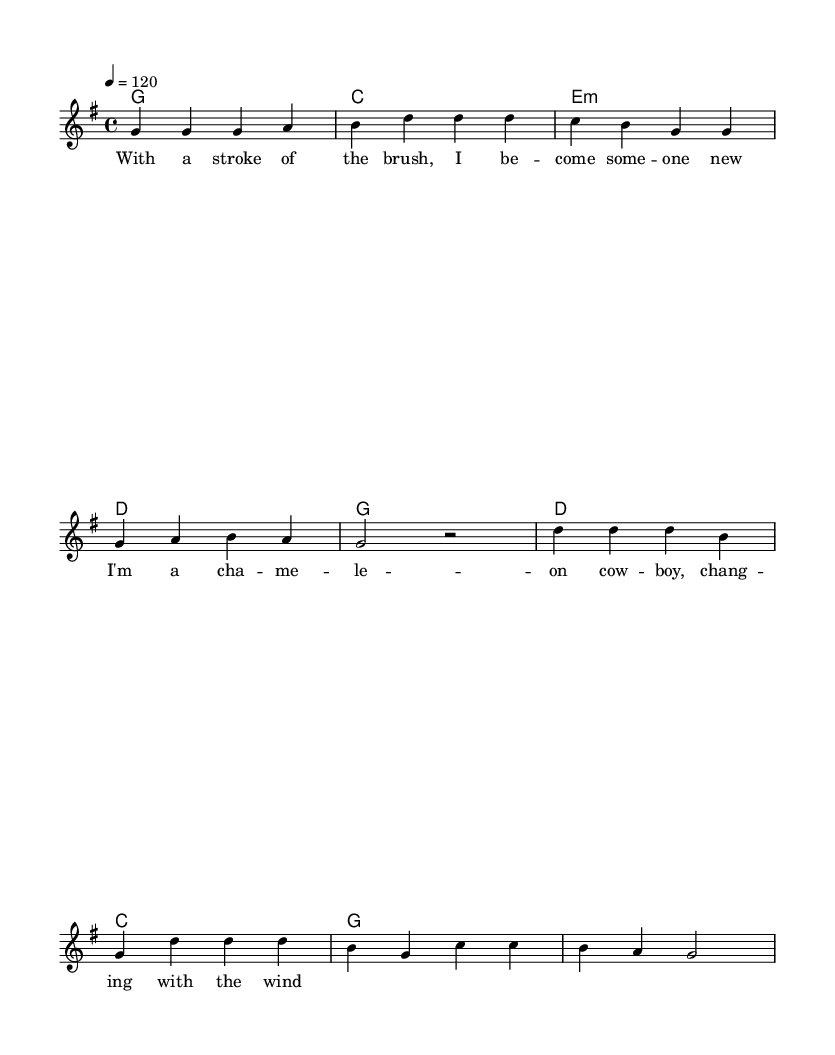What is the key signature of this music? The key signature is G major, which has one sharp (F#). You can determine this by looking at the beginning of the sheet music where the key is indicated.
Answer: G major What is the time signature of this music? The time signature is 4/4, which signifies that there are four beats in each measure and the quarter note gets one beat. This is shown near the beginning of the music where the time signature is notated.
Answer: 4/4 What is the tempo marking of this piece? The tempo marking is 120, indicating that the piece should be played at a speed of 120 beats per minute. This is found next to the "tempo" indication in the global section of the music.
Answer: 120 How many measures are in the verse section? The verse section contains 4 measures. You can count the measures based on the vertical bar lines, which divide the music into measures.
Answer: 4 What chord follows the G major chord in the verse? The chord that follows the G major chord is C major. This can be determined by looking at the chord symbols listed under the verse section.
Answer: C What phrase starts the chorus section? The phrase that starts the chorus section is "I'm a cha -- me -- le -- on cow -- boy." This is found in the lyrics section corresponding to the melody part that follows the verse.
Answer: I'm a cha -- me -- le -- on cow -- boy Which chord is the last one in the chorus? The last chord in the chorus is G major. You can find this by checking the chord symbols at the end of the chorus section in the harmonic part of the music.
Answer: G 